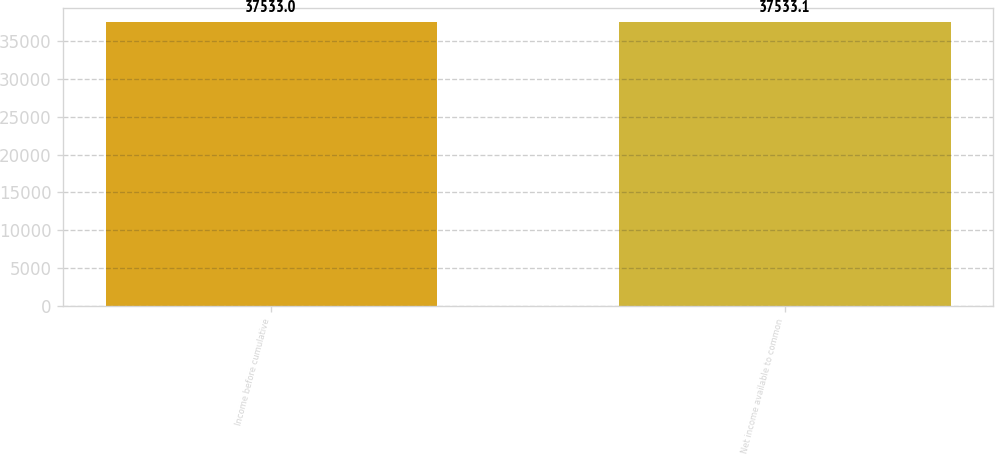Convert chart to OTSL. <chart><loc_0><loc_0><loc_500><loc_500><bar_chart><fcel>Income before cumulative<fcel>Net income available to common<nl><fcel>37533<fcel>37533.1<nl></chart> 